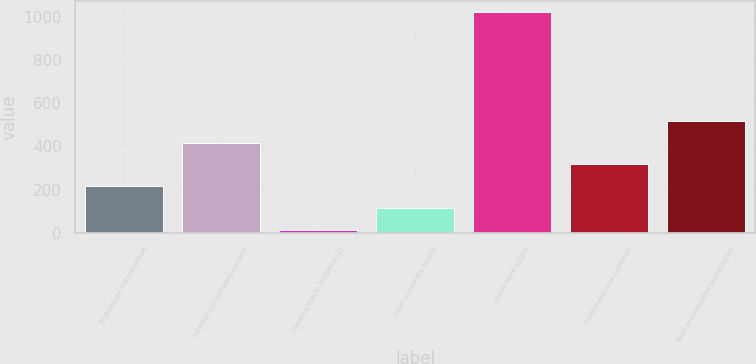Convert chart to OTSL. <chart><loc_0><loc_0><loc_500><loc_500><bar_chart><fcel>Technology infrastructure<fcel>Internal-use software content<fcel>Construction in progress (1)<fcel>Other corporate assets<fcel>Gross fixed assets<fcel>Fulfillment and customer<fcel>Total accumulated depreciation<nl><fcel>216.6<fcel>418.2<fcel>15<fcel>115.8<fcel>1023<fcel>317.4<fcel>519<nl></chart> 